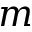Convert formula to latex. <formula><loc_0><loc_0><loc_500><loc_500>m</formula> 